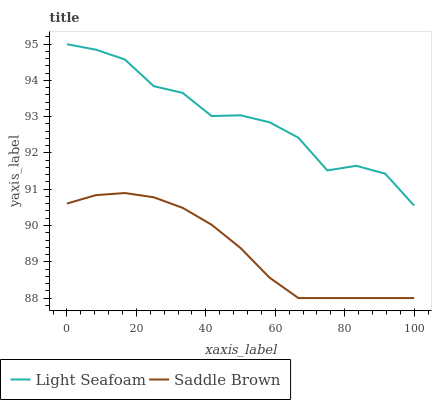Does Saddle Brown have the minimum area under the curve?
Answer yes or no. Yes. Does Light Seafoam have the maximum area under the curve?
Answer yes or no. Yes. Does Saddle Brown have the maximum area under the curve?
Answer yes or no. No. Is Saddle Brown the smoothest?
Answer yes or no. Yes. Is Light Seafoam the roughest?
Answer yes or no. Yes. Is Saddle Brown the roughest?
Answer yes or no. No. Does Saddle Brown have the lowest value?
Answer yes or no. Yes. Does Light Seafoam have the highest value?
Answer yes or no. Yes. Does Saddle Brown have the highest value?
Answer yes or no. No. Is Saddle Brown less than Light Seafoam?
Answer yes or no. Yes. Is Light Seafoam greater than Saddle Brown?
Answer yes or no. Yes. Does Saddle Brown intersect Light Seafoam?
Answer yes or no. No. 